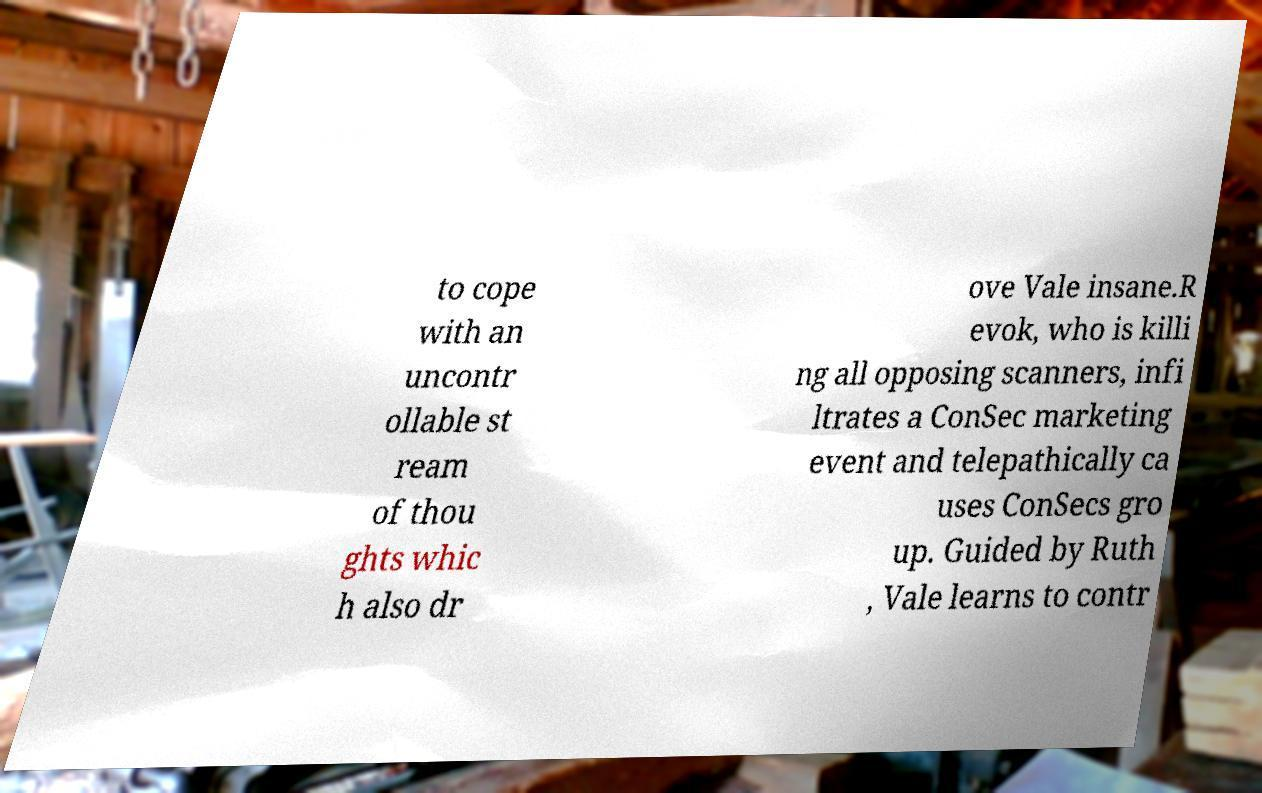Please read and relay the text visible in this image. What does it say? to cope with an uncontr ollable st ream of thou ghts whic h also dr ove Vale insane.R evok, who is killi ng all opposing scanners, infi ltrates a ConSec marketing event and telepathically ca uses ConSecs gro up. Guided by Ruth , Vale learns to contr 